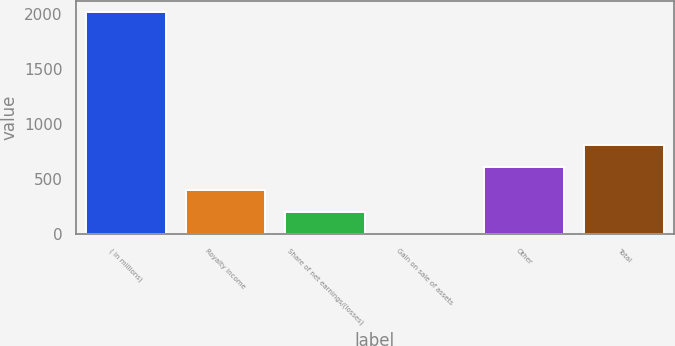<chart> <loc_0><loc_0><loc_500><loc_500><bar_chart><fcel>( in millions)<fcel>Royalty income<fcel>Share of net earnings/(losses)<fcel>Gain on sale of assets<fcel>Other<fcel>Total<nl><fcel>2015<fcel>406.2<fcel>205.1<fcel>4<fcel>607.3<fcel>808.4<nl></chart> 